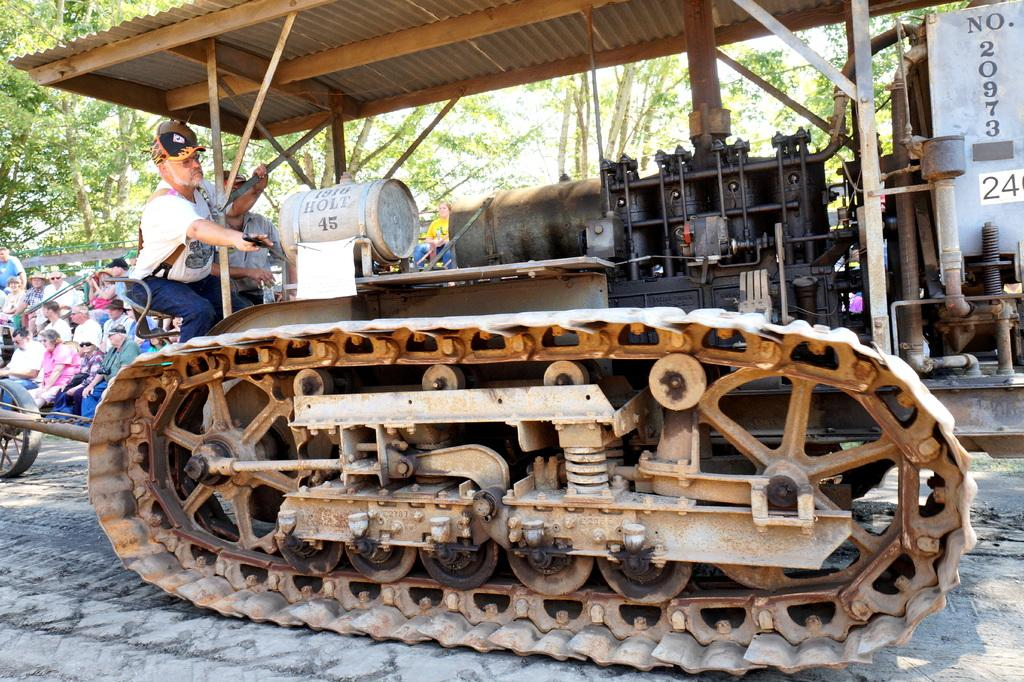How many persons are in the image? There are persons in the image. What structure can be seen in the image? There is a shed in the image. What type of equipment is present in the image? There is a machine in the image. What can be seen in the background of the image? There are trees and the sky visible in the background of the image. What type of alarm can be heard going off in the image? There is no alarm present or audible in the image. What type of plough is being used by the persons in the image? There is no plough present in the image; it features a shed, a machine, and persons. 